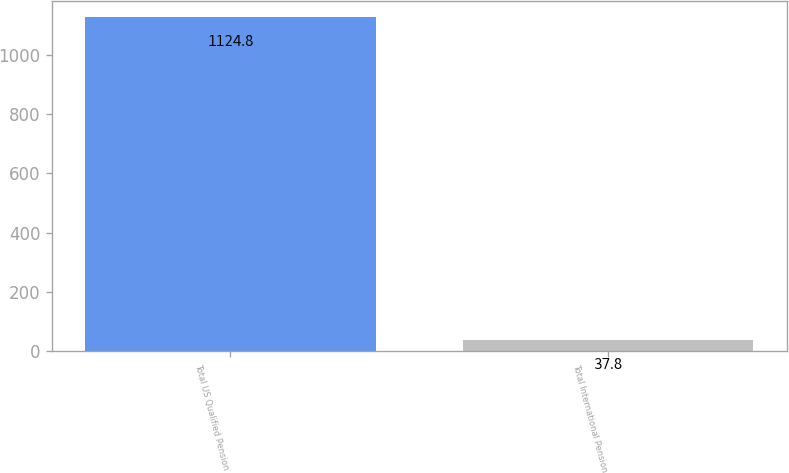<chart> <loc_0><loc_0><loc_500><loc_500><bar_chart><fcel>Total US Qualified Pension<fcel>Total International Pension<nl><fcel>1124.8<fcel>37.8<nl></chart> 